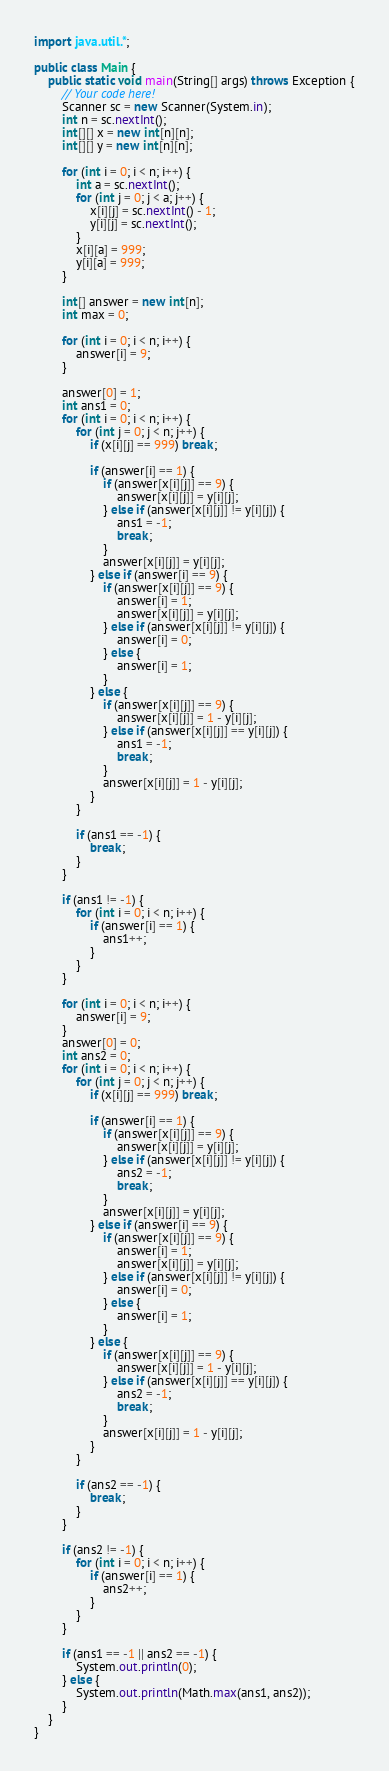<code> <loc_0><loc_0><loc_500><loc_500><_Java_>import java.util.*;

public class Main {
    public static void main(String[] args) throws Exception {
        // Your code here!
        Scanner sc = new Scanner(System.in);
        int n = sc.nextInt();
        int[][] x = new int[n][n];
        int[][] y = new int[n][n];
        
        for (int i = 0; i < n; i++) {
            int a = sc.nextInt();
            for (int j = 0; j < a; j++) {
                x[i][j] = sc.nextInt() - 1;
                y[i][j] = sc.nextInt();
            }
            x[i][a] = 999;
            y[i][a] = 999;
        }
        
        int[] answer = new int[n];
        int max = 0;
        
        for (int i = 0; i < n; i++) {
            answer[i] = 9;
        }
        
        answer[0] = 1;
        int ans1 = 0;
        for (int i = 0; i < n; i++) {
            for (int j = 0; j < n; j++) {
                if (x[i][j] == 999) break;
                
                if (answer[i] == 1) {
                    if (answer[x[i][j]] == 9) {
                        answer[x[i][j]] = y[i][j];
                    } else if (answer[x[i][j]] != y[i][j]) {
                        ans1 = -1;
                        break;
                    }
                    answer[x[i][j]] = y[i][j];
                } else if (answer[i] == 9) {
                    if (answer[x[i][j]] == 9) {
                        answer[i] = 1;
                        answer[x[i][j]] = y[i][j];
                    } else if (answer[x[i][j]] != y[i][j]) {
                        answer[i] = 0;
                    } else {
                        answer[i] = 1;
                    }
                } else {
                    if (answer[x[i][j]] == 9) {
                        answer[x[i][j]] = 1 - y[i][j];
                    } else if (answer[x[i][j]] == y[i][j]) {
                        ans1 = -1;
                        break;
                    }
                    answer[x[i][j]] = 1 - y[i][j];
                }
            }
            
            if (ans1 == -1) {
                break;
            }
        }
        
        if (ans1 != -1) {
            for (int i = 0; i < n; i++) {
                if (answer[i] == 1) {
                    ans1++;
                }
            }
        }
        
        for (int i = 0; i < n; i++) {
            answer[i] = 9;
        }
        answer[0] = 0;
        int ans2 = 0;
        for (int i = 0; i < n; i++) {
            for (int j = 0; j < n; j++) {
                if (x[i][j] == 999) break;
                
                if (answer[i] == 1) {
                    if (answer[x[i][j]] == 9) {
                        answer[x[i][j]] = y[i][j];
                    } else if (answer[x[i][j]] != y[i][j]) {
                        ans2 = -1;
                        break;
                    }
                    answer[x[i][j]] = y[i][j];
                } else if (answer[i] == 9) {
                    if (answer[x[i][j]] == 9) {
                        answer[i] = 1;
                        answer[x[i][j]] = y[i][j];
                    } else if (answer[x[i][j]] != y[i][j]) {
                        answer[i] = 0;
                    } else {
                        answer[i] = 1;
                    }
                } else {
                    if (answer[x[i][j]] == 9) {
                        answer[x[i][j]] = 1 - y[i][j];
                    } else if (answer[x[i][j]] == y[i][j]) {
                        ans2 = -1;
                        break;
                    }
                    answer[x[i][j]] = 1 - y[i][j];
                }
            }
            
            if (ans2 == -1) {
                break;
            }
        }
        
        if (ans2 != -1) {
            for (int i = 0; i < n; i++) {
                if (answer[i] == 1) {
                    ans2++;
                }
            }
        }
        
        if (ans1 == -1 || ans2 == -1) {
            System.out.println(0);
        } else {
            System.out.println(Math.max(ans1, ans2));
        }
    }
}
</code> 